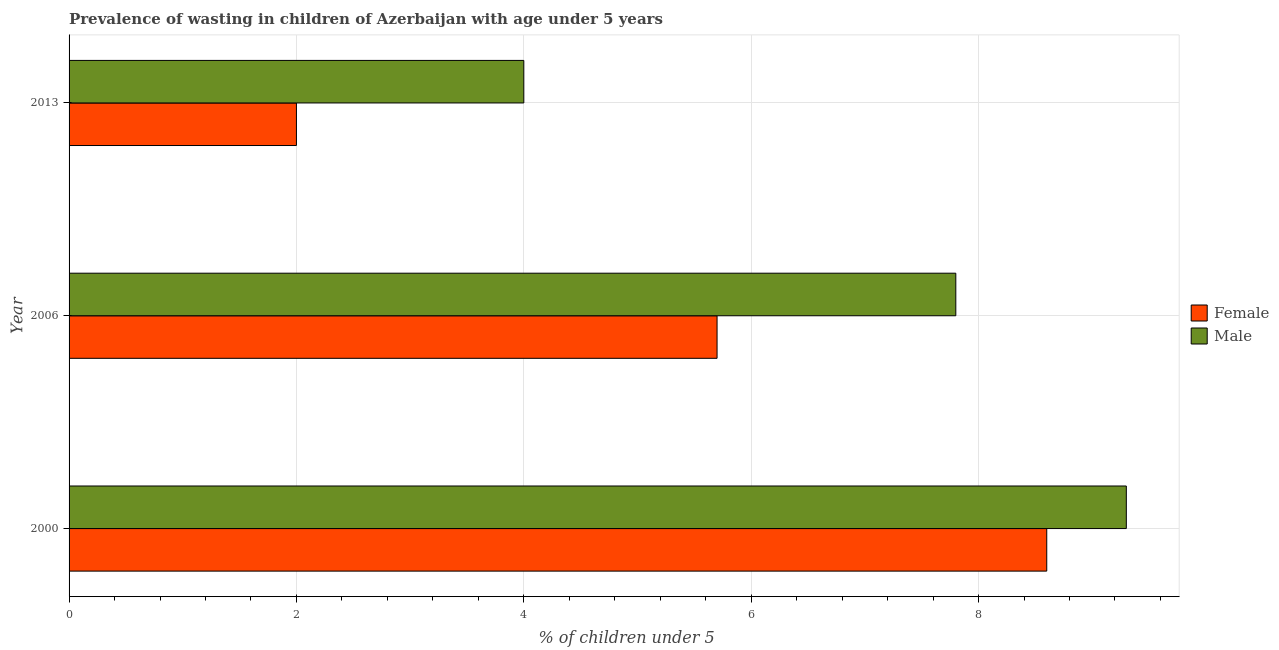How many different coloured bars are there?
Give a very brief answer. 2. How many bars are there on the 3rd tick from the top?
Provide a succinct answer. 2. What is the label of the 3rd group of bars from the top?
Provide a short and direct response. 2000. What is the percentage of undernourished female children in 2000?
Offer a terse response. 8.6. Across all years, what is the maximum percentage of undernourished male children?
Ensure brevity in your answer.  9.3. Across all years, what is the minimum percentage of undernourished male children?
Give a very brief answer. 4. In which year was the percentage of undernourished female children maximum?
Ensure brevity in your answer.  2000. What is the total percentage of undernourished male children in the graph?
Provide a short and direct response. 21.1. What is the difference between the percentage of undernourished female children in 2000 and that in 2013?
Offer a terse response. 6.6. What is the difference between the percentage of undernourished male children in 2000 and the percentage of undernourished female children in 2013?
Ensure brevity in your answer.  7.3. What is the average percentage of undernourished female children per year?
Offer a terse response. 5.43. In how many years, is the percentage of undernourished female children greater than 8 %?
Offer a very short reply. 1. What is the ratio of the percentage of undernourished male children in 2000 to that in 2006?
Make the answer very short. 1.19. What is the difference between the highest and the lowest percentage of undernourished female children?
Keep it short and to the point. 6.6. Is the sum of the percentage of undernourished male children in 2006 and 2013 greater than the maximum percentage of undernourished female children across all years?
Your answer should be compact. Yes. Are all the bars in the graph horizontal?
Provide a short and direct response. Yes. How many years are there in the graph?
Provide a succinct answer. 3. What is the difference between two consecutive major ticks on the X-axis?
Your answer should be very brief. 2. Are the values on the major ticks of X-axis written in scientific E-notation?
Provide a short and direct response. No. Does the graph contain any zero values?
Your answer should be compact. No. Where does the legend appear in the graph?
Your answer should be compact. Center right. How are the legend labels stacked?
Offer a very short reply. Vertical. What is the title of the graph?
Offer a very short reply. Prevalence of wasting in children of Azerbaijan with age under 5 years. Does "Public credit registry" appear as one of the legend labels in the graph?
Provide a short and direct response. No. What is the label or title of the X-axis?
Provide a short and direct response.  % of children under 5. What is the  % of children under 5 of Female in 2000?
Provide a succinct answer. 8.6. What is the  % of children under 5 in Male in 2000?
Provide a succinct answer. 9.3. What is the  % of children under 5 of Female in 2006?
Keep it short and to the point. 5.7. What is the  % of children under 5 in Male in 2006?
Your response must be concise. 7.8. Across all years, what is the maximum  % of children under 5 of Female?
Provide a succinct answer. 8.6. Across all years, what is the maximum  % of children under 5 in Male?
Your answer should be compact. 9.3. What is the total  % of children under 5 in Male in the graph?
Your response must be concise. 21.1. What is the difference between the  % of children under 5 of Male in 2006 and that in 2013?
Ensure brevity in your answer.  3.8. What is the difference between the  % of children under 5 of Female in 2000 and the  % of children under 5 of Male in 2006?
Offer a terse response. 0.8. What is the difference between the  % of children under 5 of Female in 2000 and the  % of children under 5 of Male in 2013?
Your answer should be compact. 4.6. What is the average  % of children under 5 in Female per year?
Give a very brief answer. 5.43. What is the average  % of children under 5 in Male per year?
Your response must be concise. 7.03. In the year 2000, what is the difference between the  % of children under 5 in Female and  % of children under 5 in Male?
Your answer should be compact. -0.7. In the year 2013, what is the difference between the  % of children under 5 of Female and  % of children under 5 of Male?
Keep it short and to the point. -2. What is the ratio of the  % of children under 5 in Female in 2000 to that in 2006?
Your response must be concise. 1.51. What is the ratio of the  % of children under 5 in Male in 2000 to that in 2006?
Ensure brevity in your answer.  1.19. What is the ratio of the  % of children under 5 of Female in 2000 to that in 2013?
Your response must be concise. 4.3. What is the ratio of the  % of children under 5 in Male in 2000 to that in 2013?
Your answer should be very brief. 2.33. What is the ratio of the  % of children under 5 in Female in 2006 to that in 2013?
Provide a short and direct response. 2.85. What is the ratio of the  % of children under 5 in Male in 2006 to that in 2013?
Provide a short and direct response. 1.95. What is the difference between the highest and the second highest  % of children under 5 in Male?
Your answer should be very brief. 1.5. What is the difference between the highest and the lowest  % of children under 5 in Female?
Your answer should be compact. 6.6. What is the difference between the highest and the lowest  % of children under 5 in Male?
Ensure brevity in your answer.  5.3. 